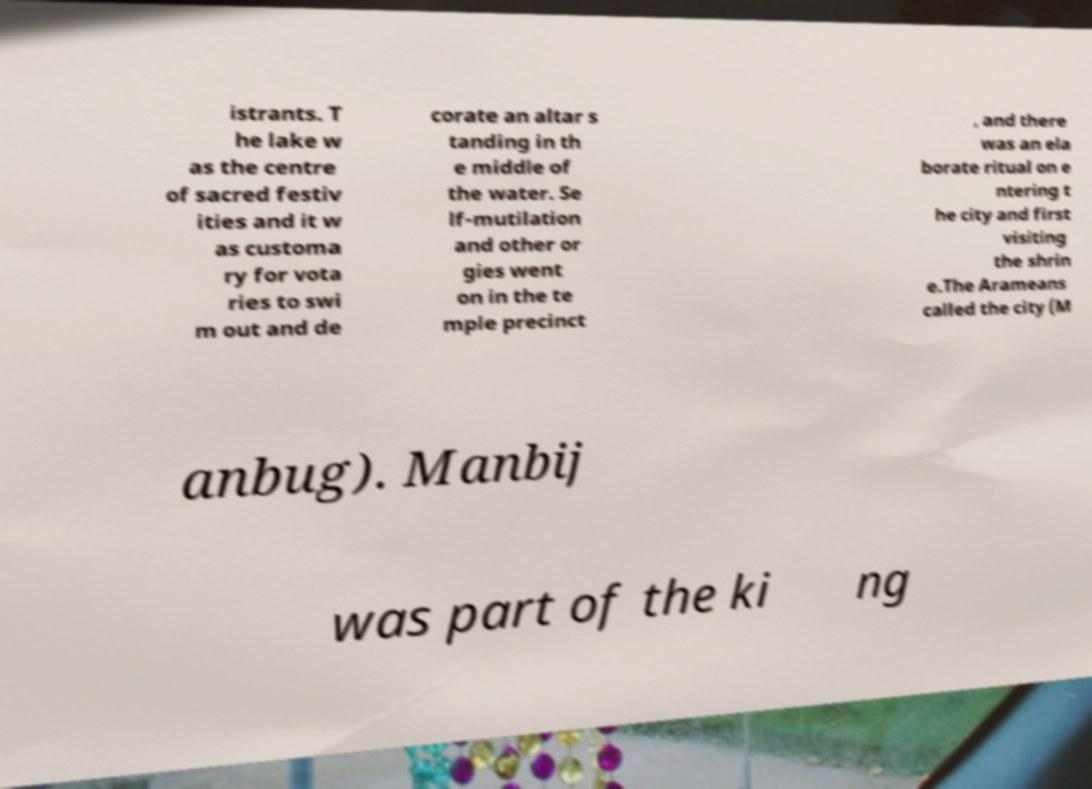What messages or text are displayed in this image? I need them in a readable, typed format. istrants. T he lake w as the centre of sacred festiv ities and it w as customa ry for vota ries to swi m out and de corate an altar s tanding in th e middle of the water. Se lf-mutilation and other or gies went on in the te mple precinct , and there was an ela borate ritual on e ntering t he city and first visiting the shrin e.The Arameans called the city (M anbug). Manbij was part of the ki ng 